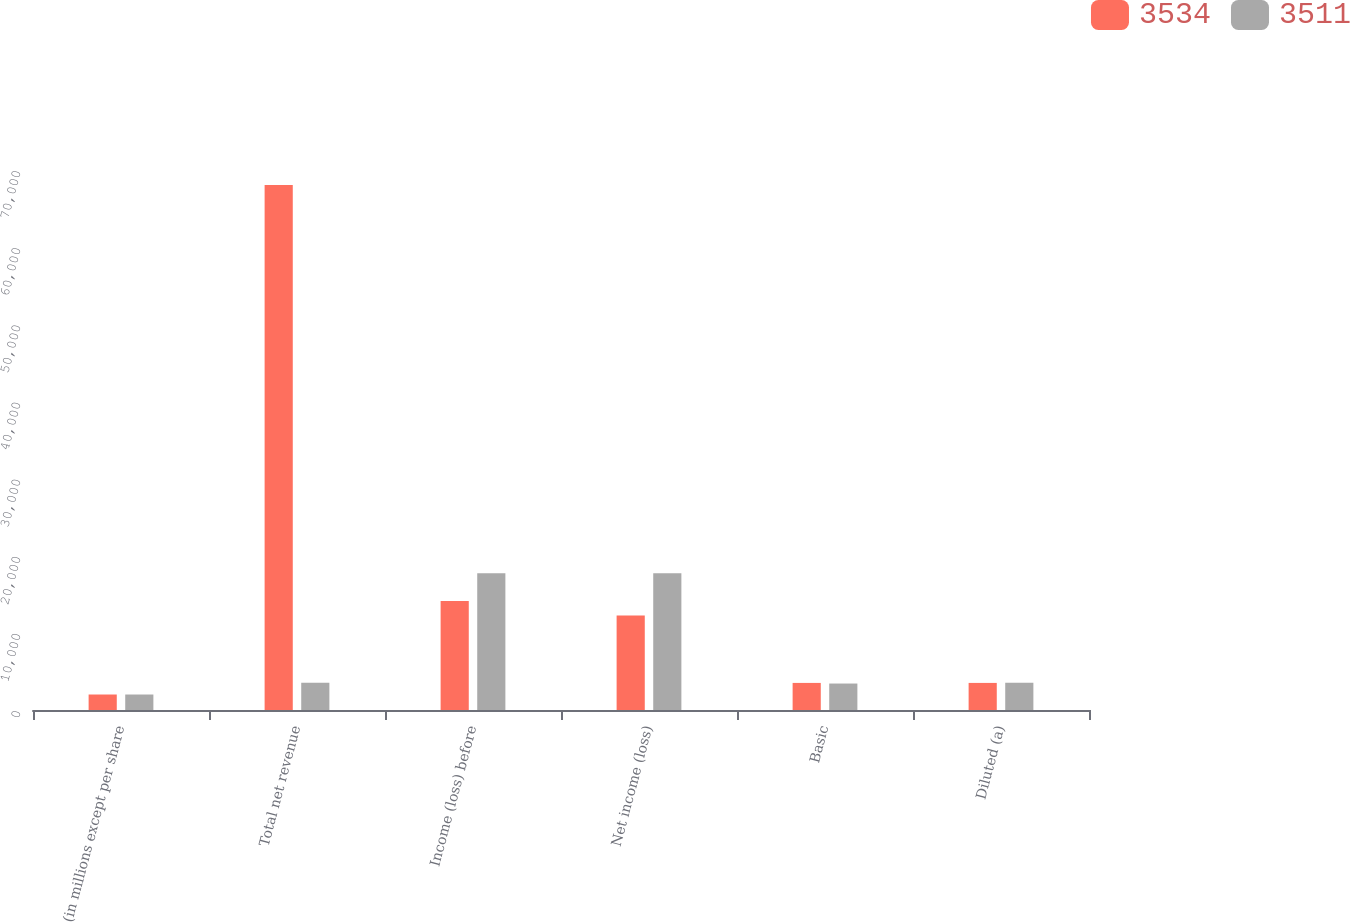Convert chart to OTSL. <chart><loc_0><loc_0><loc_500><loc_500><stacked_bar_chart><ecel><fcel>(in millions except per share<fcel>Total net revenue<fcel>Income (loss) before<fcel>Net income (loss)<fcel>Basic<fcel>Diluted (a)<nl><fcel>3534<fcel>2008<fcel>68071<fcel>14141<fcel>12235<fcel>3511<fcel>3511<nl><fcel>3511<fcel>2007<fcel>3534<fcel>17733<fcel>17733<fcel>3430<fcel>3534<nl></chart> 